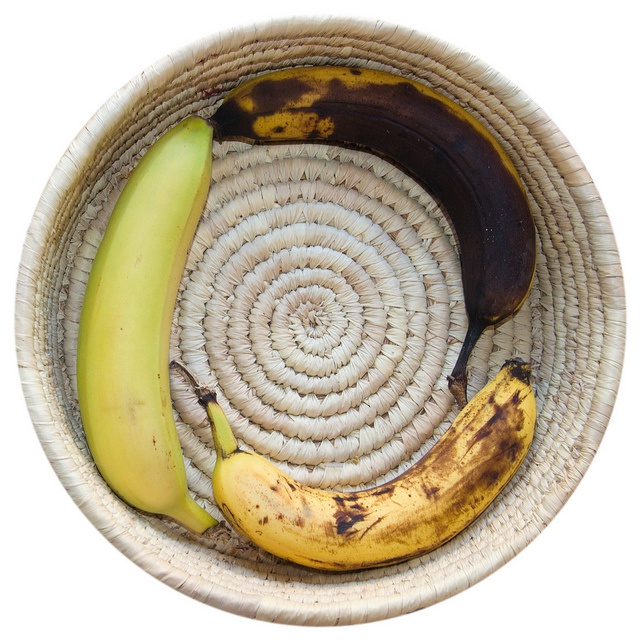Describe the objects in this image and their specific colors. I can see bowl in white, lightgray, darkgray, tan, and black tones, banana in white, khaki, olive, and tan tones, banana in white, black, maroon, and olive tones, and banana in white, tan, khaki, olive, and orange tones in this image. 